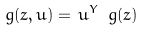<formula> <loc_0><loc_0><loc_500><loc_500>\ g ( z , u ) = \, u ^ { Y } \ g ( z )</formula> 